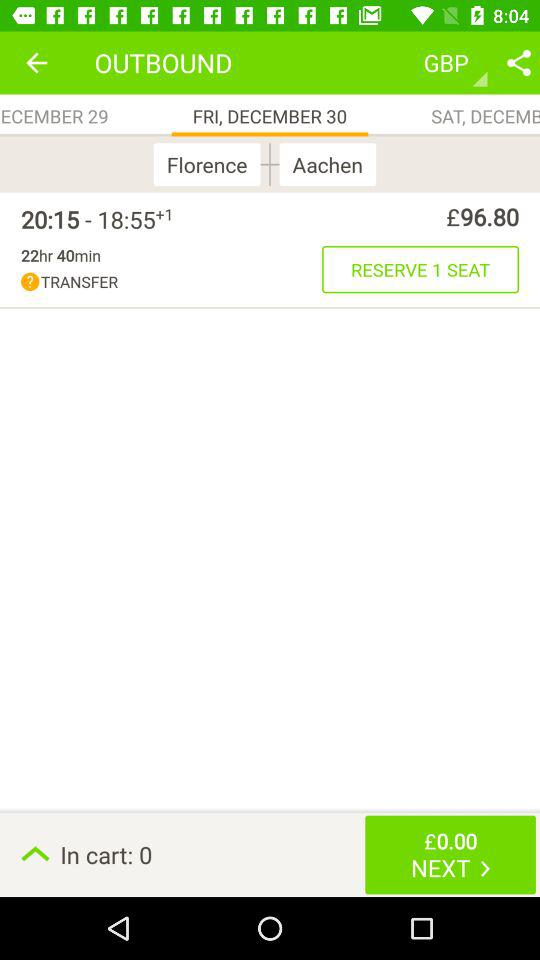How many things are in the cart? There are 0 things in the cart. 